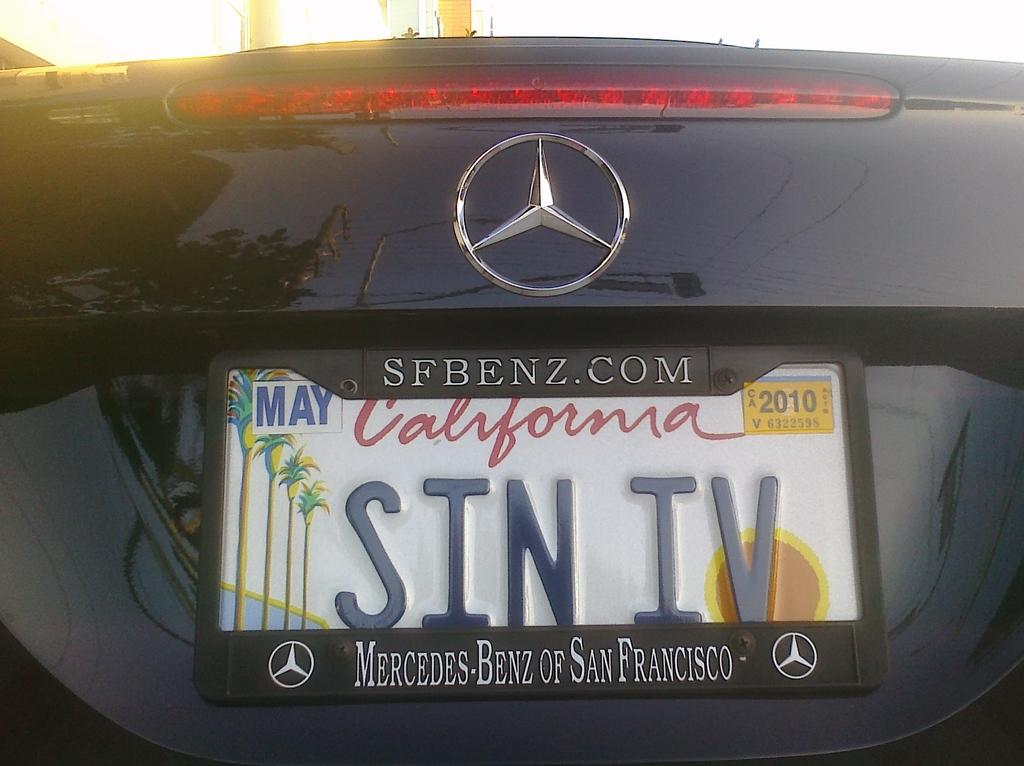<image>
Render a clear and concise summary of the photo. A Mercedes Benz with a California tag that says SIN IV. 